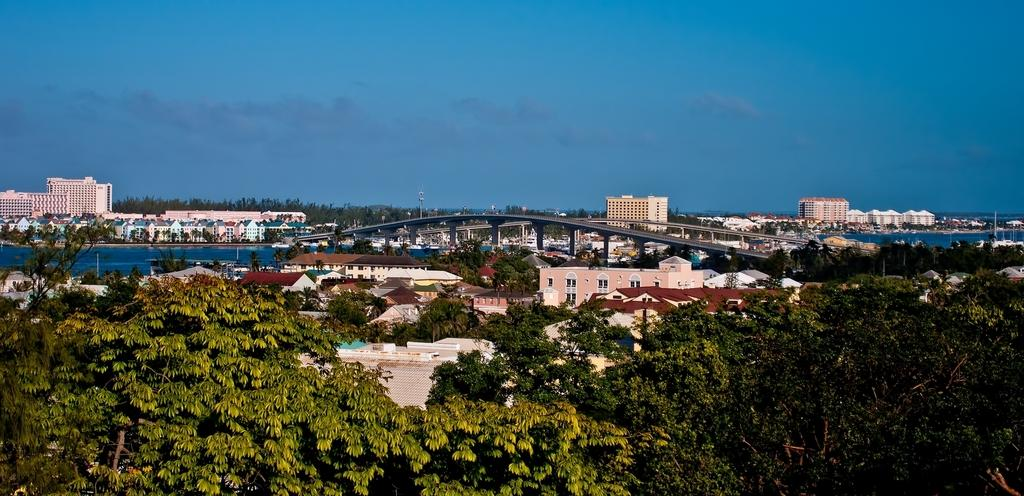What type of view is depicted in the image? The image is an aerial view. What type of natural elements can be seen in the image? There are trees, plants, and clouds visible in the image. What type of man-made structures can be seen in the image? There are buildings, houses, a bridge, poles, and a road visible in the image. What part of the natural environment is visible in the image? The sky is visible in the image. Can you see any yaks or turkeys in the image? No, there are no yaks or turkeys present in the image. How many hours of sleep can be seen in the image? Sleep is not visible in the image, as it is a photograph of an aerial view of a landscape. 